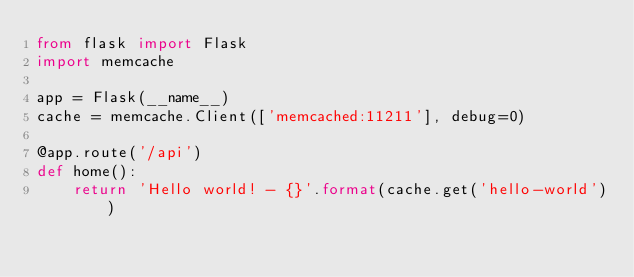Convert code to text. <code><loc_0><loc_0><loc_500><loc_500><_Python_>from flask import Flask
import memcache

app = Flask(__name__)
cache = memcache.Client(['memcached:11211'], debug=0)

@app.route('/api')
def home():
    return 'Hello world! - {}'.format(cache.get('hello-world'))

</code> 